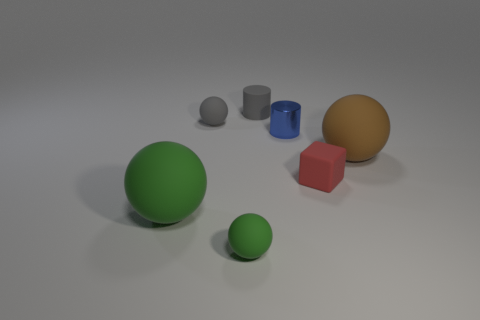There is a thing that is the same color as the tiny rubber cylinder; what is its material?
Provide a succinct answer. Rubber. How many small rubber objects are the same color as the matte cylinder?
Make the answer very short. 1. There is a rubber thing that is the same color as the small rubber cylinder; what is its size?
Ensure brevity in your answer.  Small. Do the large thing that is left of the big brown matte sphere and the small matte ball in front of the blue thing have the same color?
Offer a terse response. Yes. The cylinder that is the same size as the shiny object is what color?
Offer a very short reply. Gray. Is there a big matte thing of the same color as the small metallic cylinder?
Keep it short and to the point. No. There is a matte sphere that is behind the brown rubber object; is it the same size as the tiny matte cylinder?
Your answer should be very brief. Yes. Are there the same number of green things that are in front of the large green matte sphere and small green matte things?
Ensure brevity in your answer.  Yes. How many things are spheres that are behind the shiny cylinder or small red rubber objects?
Make the answer very short. 2. The tiny rubber thing that is left of the red matte block and in front of the small gray matte ball has what shape?
Offer a terse response. Sphere. 